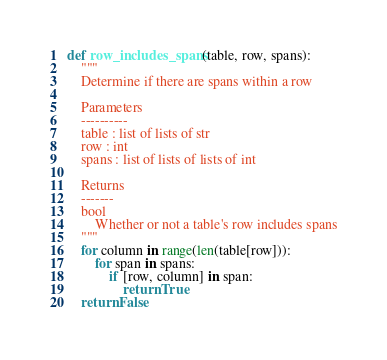Convert code to text. <code><loc_0><loc_0><loc_500><loc_500><_Python_>def row_includes_spans(table, row, spans):
    """
    Determine if there are spans within a row

    Parameters
    ----------
    table : list of lists of str
    row : int
    spans : list of lists of lists of int

    Returns
    -------
    bool
        Whether or not a table's row includes spans
    """
    for column in range(len(table[row])):
        for span in spans:
            if [row, column] in span:
                return True
    return False
</code> 